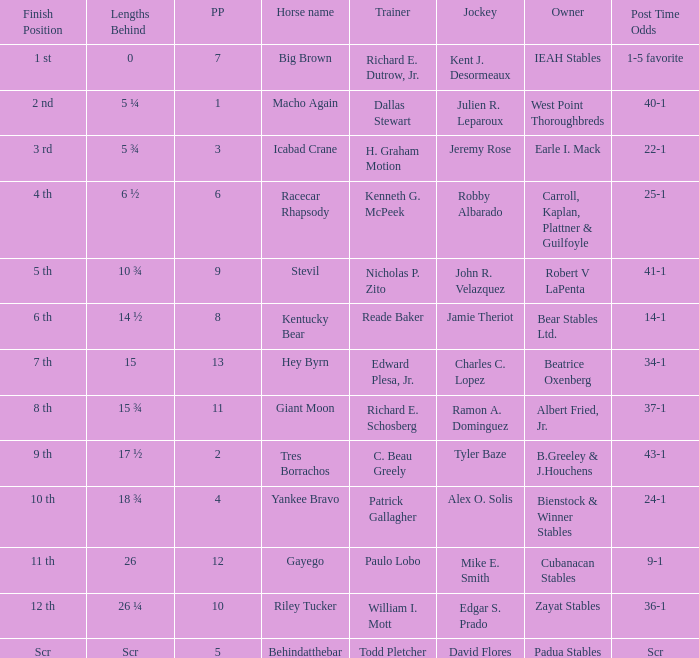Could you parse the entire table? {'header': ['Finish Position', 'Lengths Behind', 'PP', 'Horse name', 'Trainer', 'Jockey', 'Owner', 'Post Time Odds'], 'rows': [['1 st', '0', '7', 'Big Brown', 'Richard E. Dutrow, Jr.', 'Kent J. Desormeaux', 'IEAH Stables', '1-5 favorite'], ['2 nd', '5 ¼', '1', 'Macho Again', 'Dallas Stewart', 'Julien R. Leparoux', 'West Point Thoroughbreds', '40-1'], ['3 rd', '5 ¾', '3', 'Icabad Crane', 'H. Graham Motion', 'Jeremy Rose', 'Earle I. Mack', '22-1'], ['4 th', '6 ½', '6', 'Racecar Rhapsody', 'Kenneth G. McPeek', 'Robby Albarado', 'Carroll, Kaplan, Plattner & Guilfoyle', '25-1'], ['5 th', '10 ¾', '9', 'Stevil', 'Nicholas P. Zito', 'John R. Velazquez', 'Robert V LaPenta', '41-1'], ['6 th', '14 ½', '8', 'Kentucky Bear', 'Reade Baker', 'Jamie Theriot', 'Bear Stables Ltd.', '14-1'], ['7 th', '15', '13', 'Hey Byrn', 'Edward Plesa, Jr.', 'Charles C. Lopez', 'Beatrice Oxenberg', '34-1'], ['8 th', '15 ¾', '11', 'Giant Moon', 'Richard E. Schosberg', 'Ramon A. Dominguez', 'Albert Fried, Jr.', '37-1'], ['9 th', '17 ½', '2', 'Tres Borrachos', 'C. Beau Greely', 'Tyler Baze', 'B.Greeley & J.Houchens', '43-1'], ['10 th', '18 ¾', '4', 'Yankee Bravo', 'Patrick Gallagher', 'Alex O. Solis', 'Bienstock & Winner Stables', '24-1'], ['11 th', '26', '12', 'Gayego', 'Paulo Lobo', 'Mike E. Smith', 'Cubanacan Stables', '9-1'], ['12 th', '26 ¼', '10', 'Riley Tucker', 'William I. Mott', 'Edgar S. Prado', 'Zayat Stables', '36-1'], ['Scr', 'Scr', '5', 'Behindatthebar', 'Todd Pletcher', 'David Flores', 'Padua Stables', 'Scr']]} What is the lengths behind of Jeremy Rose? 5 ¾. 